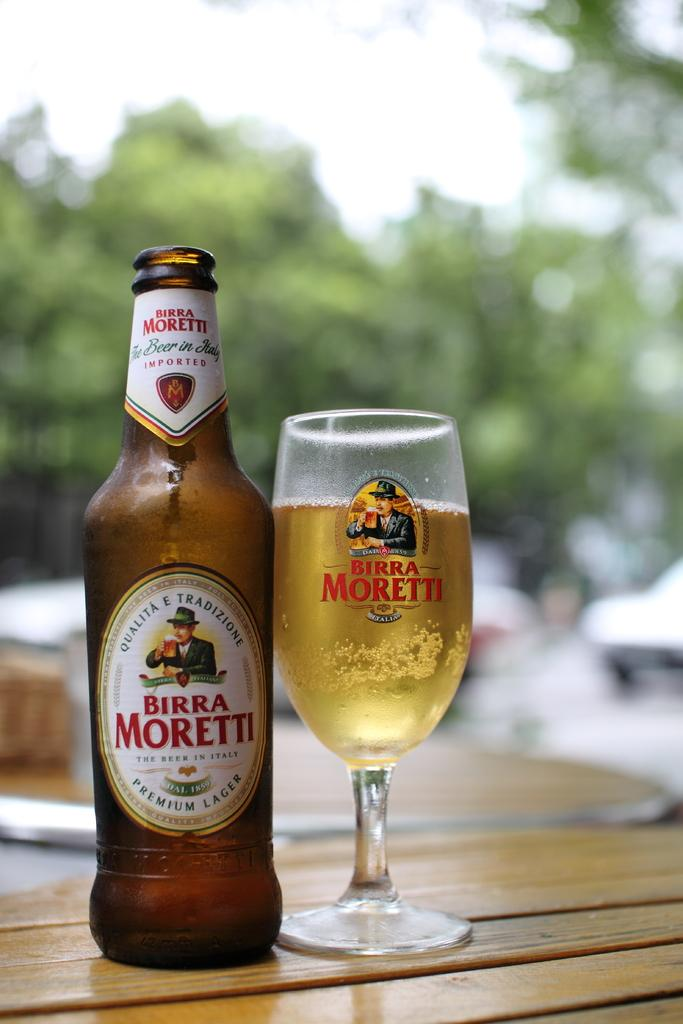<image>
Create a compact narrative representing the image presented. A bottle of Birra Moretti beer next to a glass of the same 